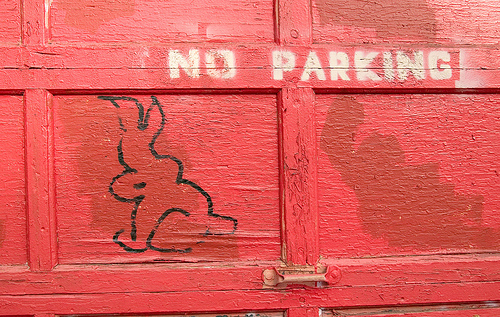<image>
Can you confirm if the rabbit is on the red door? Yes. Looking at the image, I can see the rabbit is positioned on top of the red door, with the red door providing support. 